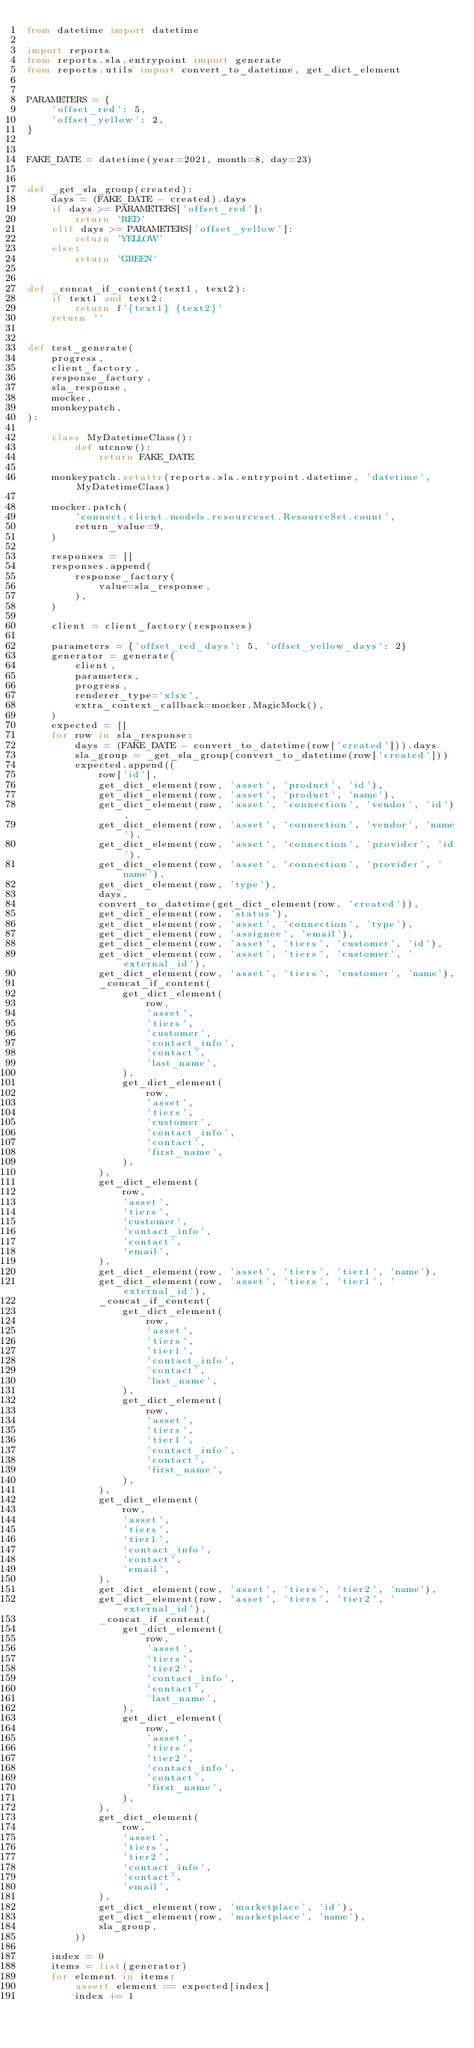Convert code to text. <code><loc_0><loc_0><loc_500><loc_500><_Python_>from datetime import datetime

import reports
from reports.sla.entrypoint import generate
from reports.utils import convert_to_datetime, get_dict_element


PARAMETERS = {
    'offset_red': 5,
    'offset_yellow': 2,
}


FAKE_DATE = datetime(year=2021, month=8, day=23)


def _get_sla_group(created):
    days = (FAKE_DATE - created).days
    if days >= PARAMETERS['offset_red']:
        return 'RED'
    elif days >= PARAMETERS['offset_yellow']:
        return 'YELLOW'
    else:
        return 'GREEN'


def _concat_if_content(text1, text2):
    if text1 and text2:
        return f'{text1} {text2}'
    return ''


def test_generate(
    progress,
    client_factory,
    response_factory,
    sla_response,
    mocker,
    monkeypatch,
):

    class MyDatetimeClass():
        def utcnow():
            return FAKE_DATE

    monkeypatch.setattr(reports.sla.entrypoint.datetime, 'datetime', MyDatetimeClass)

    mocker.patch(
        'connect.client.models.resourceset.ResourceSet.count',
        return_value=9,
    )

    responses = []
    responses.append(
        response_factory(
            value=sla_response,
        ),
    )

    client = client_factory(responses)

    parameters = {'offset_red_days': 5, 'offset_yellow_days': 2}
    generator = generate(
        client,
        parameters,
        progress,
        renderer_type='xlsx',
        extra_context_callback=mocker.MagicMock(),
    )
    expected = []
    for row in sla_response:
        days = (FAKE_DATE - convert_to_datetime(row['created'])).days
        sla_group = _get_sla_group(convert_to_datetime(row['created']))
        expected.append((
            row['id'],
            get_dict_element(row, 'asset', 'product', 'id'),
            get_dict_element(row, 'asset', 'product', 'name'),
            get_dict_element(row, 'asset', 'connection', 'vendor', 'id'),
            get_dict_element(row, 'asset', 'connection', 'vendor', 'name'),
            get_dict_element(row, 'asset', 'connection', 'provider', 'id'),
            get_dict_element(row, 'asset', 'connection', 'provider', 'name'),
            get_dict_element(row, 'type'),
            days,
            convert_to_datetime(get_dict_element(row, 'created')),
            get_dict_element(row, 'status'),
            get_dict_element(row, 'asset', 'connection', 'type'),
            get_dict_element(row, 'assignee', 'email'),
            get_dict_element(row, 'asset', 'tiers', 'customer', 'id'),
            get_dict_element(row, 'asset', 'tiers', 'customer', 'external_id'),
            get_dict_element(row, 'asset', 'tiers', 'customer', 'name'),
            _concat_if_content(
                get_dict_element(
                    row,
                    'asset',
                    'tiers',
                    'customer',
                    'contact_info',
                    'contact',
                    'last_name',
                ),
                get_dict_element(
                    row,
                    'asset',
                    'tiers',
                    'customer',
                    'contact_info',
                    'contact',
                    'first_name',
                ),
            ),
            get_dict_element(
                row,
                'asset',
                'tiers',
                'customer',
                'contact_info',
                'contact',
                'email',
            ),
            get_dict_element(row, 'asset', 'tiers', 'tier1', 'name'),
            get_dict_element(row, 'asset', 'tiers', 'tier1', 'external_id'),
            _concat_if_content(
                get_dict_element(
                    row,
                    'asset',
                    'tiers',
                    'tier1',
                    'contact_info',
                    'contact',
                    'last_name',
                ),
                get_dict_element(
                    row,
                    'asset',
                    'tiers',
                    'tier1',
                    'contact_info',
                    'contact',
                    'first_name',
                ),
            ),
            get_dict_element(
                row,
                'asset',
                'tiers',
                'tier1',
                'contact_info',
                'contact',
                'email',
            ),
            get_dict_element(row, 'asset', 'tiers', 'tier2', 'name'),
            get_dict_element(row, 'asset', 'tiers', 'tier2', 'external_id'),
            _concat_if_content(
                get_dict_element(
                    row,
                    'asset',
                    'tiers',
                    'tier2',
                    'contact_info',
                    'contact',
                    'last_name',
                ),
                get_dict_element(
                    row,
                    'asset',
                    'tiers',
                    'tier2',
                    'contact_info',
                    'contact',
                    'first_name',
                ),
            ),
            get_dict_element(
                row,
                'asset',
                'tiers',
                'tier2',
                'contact_info',
                'contact',
                'email',
            ),
            get_dict_element(row, 'marketplace', 'id'),
            get_dict_element(row, 'marketplace', 'name'),
            sla_group,
        ))

    index = 0
    items = list(generator)
    for element in items:
        assert element == expected[index]
        index += 1
</code> 